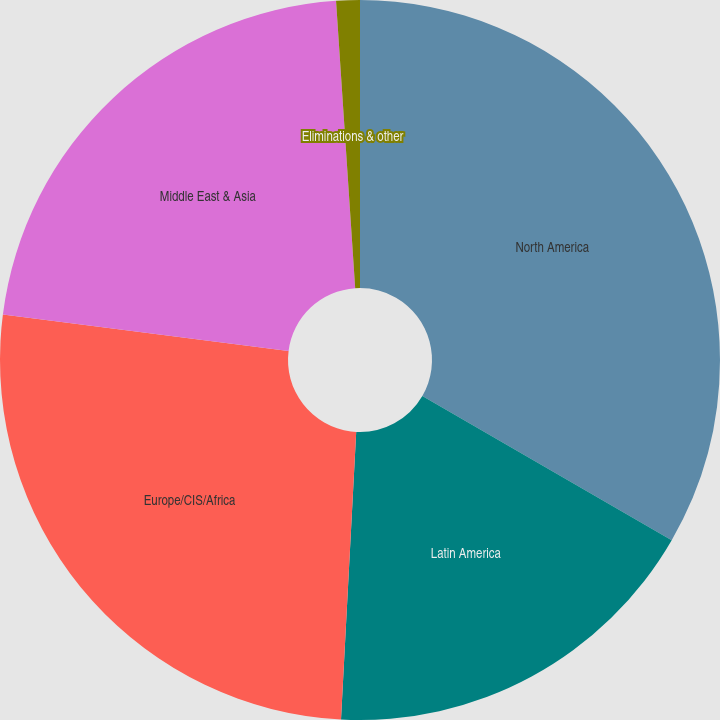Convert chart. <chart><loc_0><loc_0><loc_500><loc_500><pie_chart><fcel>North America<fcel>Latin America<fcel>Europe/CIS/Africa<fcel>Middle East & Asia<fcel>Eliminations & other<nl><fcel>33.34%<fcel>17.5%<fcel>26.18%<fcel>21.92%<fcel>1.06%<nl></chart> 